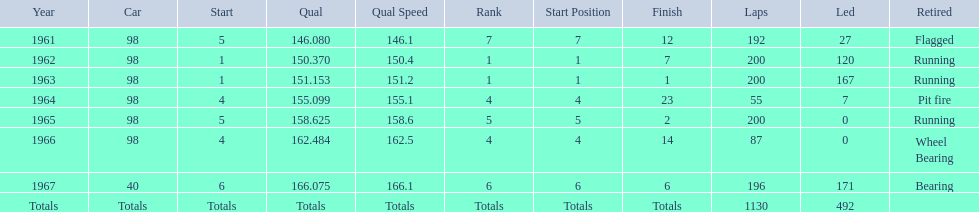What was his best finish before his first win? 7. 